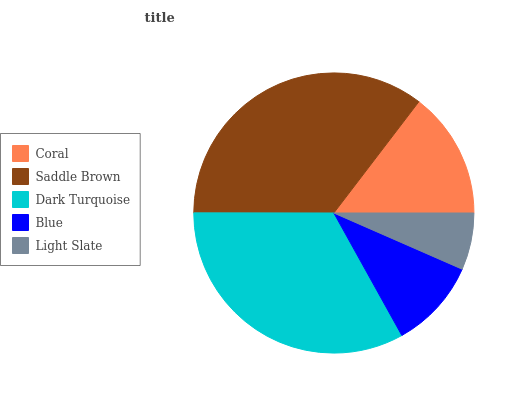Is Light Slate the minimum?
Answer yes or no. Yes. Is Saddle Brown the maximum?
Answer yes or no. Yes. Is Dark Turquoise the minimum?
Answer yes or no. No. Is Dark Turquoise the maximum?
Answer yes or no. No. Is Saddle Brown greater than Dark Turquoise?
Answer yes or no. Yes. Is Dark Turquoise less than Saddle Brown?
Answer yes or no. Yes. Is Dark Turquoise greater than Saddle Brown?
Answer yes or no. No. Is Saddle Brown less than Dark Turquoise?
Answer yes or no. No. Is Coral the high median?
Answer yes or no. Yes. Is Coral the low median?
Answer yes or no. Yes. Is Saddle Brown the high median?
Answer yes or no. No. Is Saddle Brown the low median?
Answer yes or no. No. 